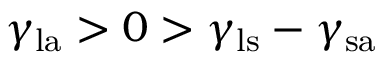Convert formula to latex. <formula><loc_0><loc_0><loc_500><loc_500>\gamma _ { l a } > 0 > \gamma _ { l s } - \gamma _ { s a }</formula> 